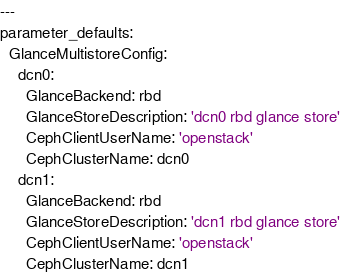<code> <loc_0><loc_0><loc_500><loc_500><_YAML_>---
parameter_defaults:
  GlanceMultistoreConfig:
    dcn0:
      GlanceBackend: rbd
      GlanceStoreDescription: 'dcn0 rbd glance store'
      CephClientUserName: 'openstack'
      CephClusterName: dcn0
    dcn1:
      GlanceBackend: rbd
      GlanceStoreDescription: 'dcn1 rbd glance store'
      CephClientUserName: 'openstack'
      CephClusterName: dcn1
</code> 